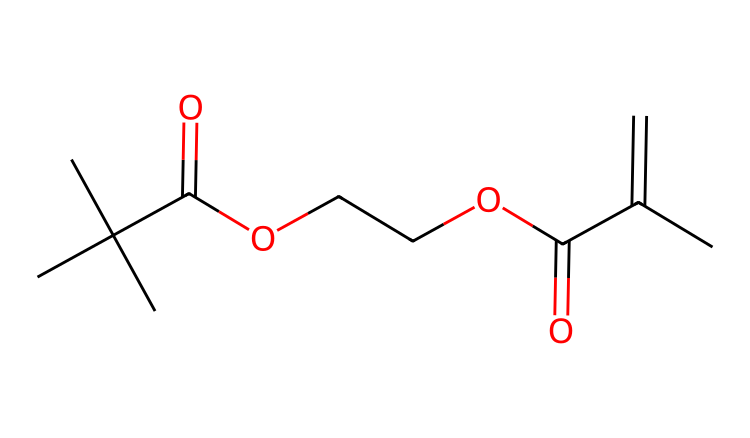What is the total number of carbon atoms in this chemical? The SMILES representation contains multiple "C" characters, which signify carbon atoms. Counting them yields a total of 10 carbon atoms present in the structure.
Answer: 10 How many oxygen atoms are present in the molecule? The SMILES representation contains the character "O" that indicates oxygen atoms. By counting these "O" characters in the structure, we find that there are 4 oxygen atoms in total.
Answer: 4 What functional group is indicated by the "C(=O)" notation? The notation "C(=O)" suggests a carbon atom double-bonded to an oxygen atom, which is characteristic of a carbonyl group. In this case, it typically represents either a ketone or an ester functional group.
Answer: carbonyl Which part of the molecule is responsible for its photoreactive properties? The presence of a "C=C" double bond in the structure is associated with photoreactivity; this part of the molecule will undergo polymerization upon exposure to UV light.
Answer: C=C Can you identify the type of chemical this molecule represents based on its structure? This molecule contains functional groups such as esters and alkene (C=C), which are typical in photoreactive chemicals, especially in UV-curable coatings. Therefore, it indicates that the chemical is a UV-curable clear coat.
Answer: UV-curable clear coat What is the degree of saturation for this molecule? To determine the degree of saturation, we assess the number of rings and multiple bonds. Each double bond increases saturation. There are 10 carbons, 4 oxygens, and one double bond, leading to a saturated nature suggesting limited entanglement. The saturated nature corresponds to lower degrees of unsaturation.
Answer: low 